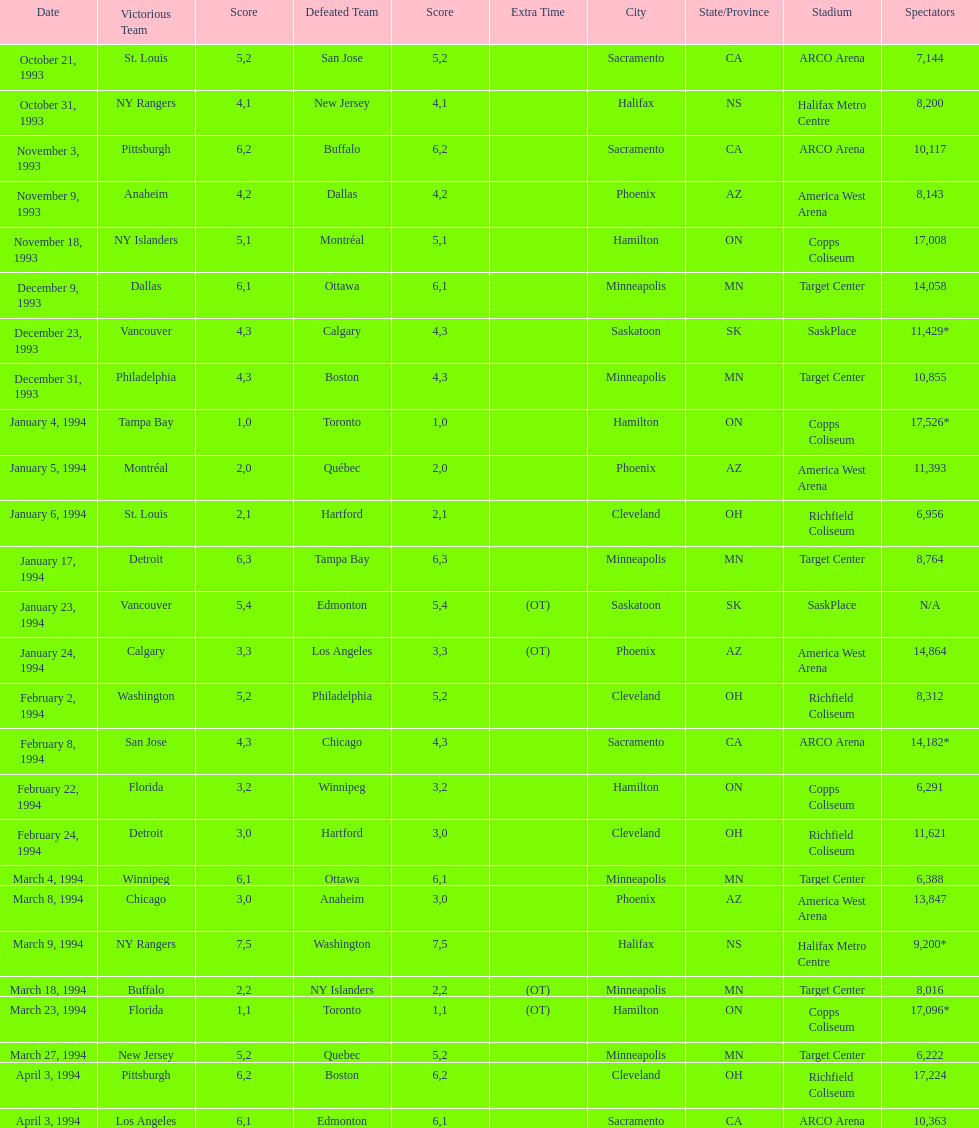How many events occurred in minneapolis, mn? 6. 